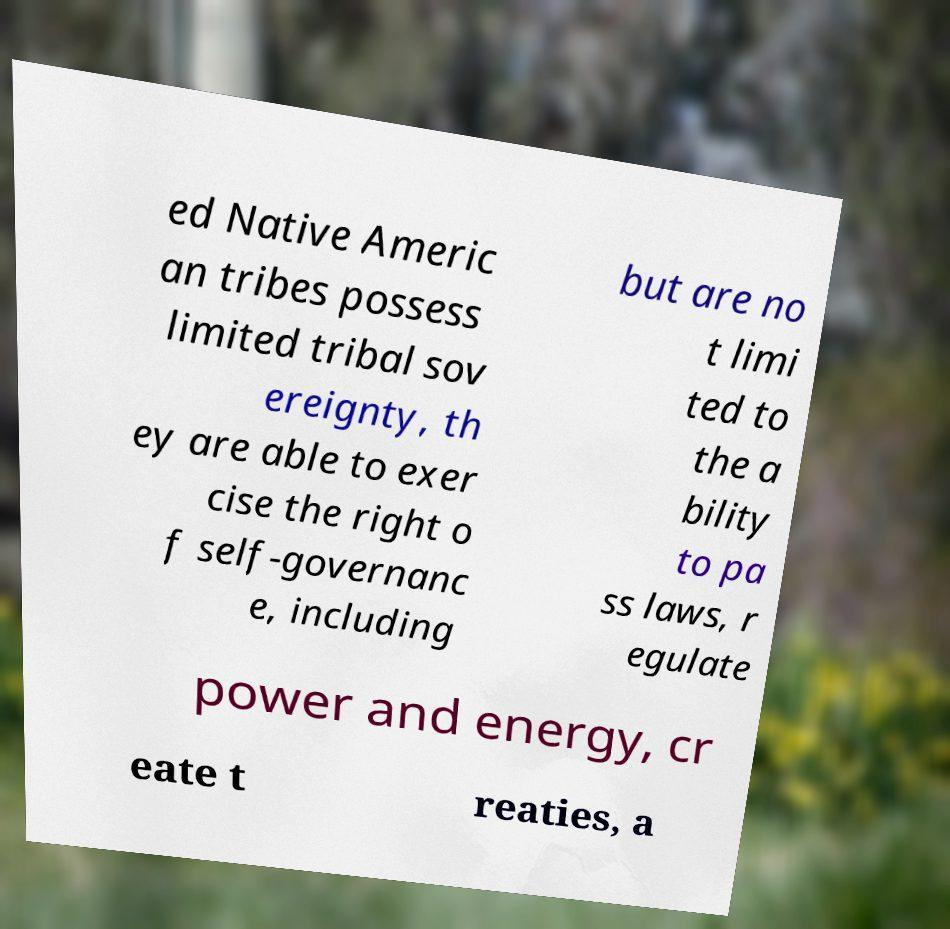There's text embedded in this image that I need extracted. Can you transcribe it verbatim? ed Native Americ an tribes possess limited tribal sov ereignty, th ey are able to exer cise the right o f self-governanc e, including but are no t limi ted to the a bility to pa ss laws, r egulate power and energy, cr eate t reaties, a 